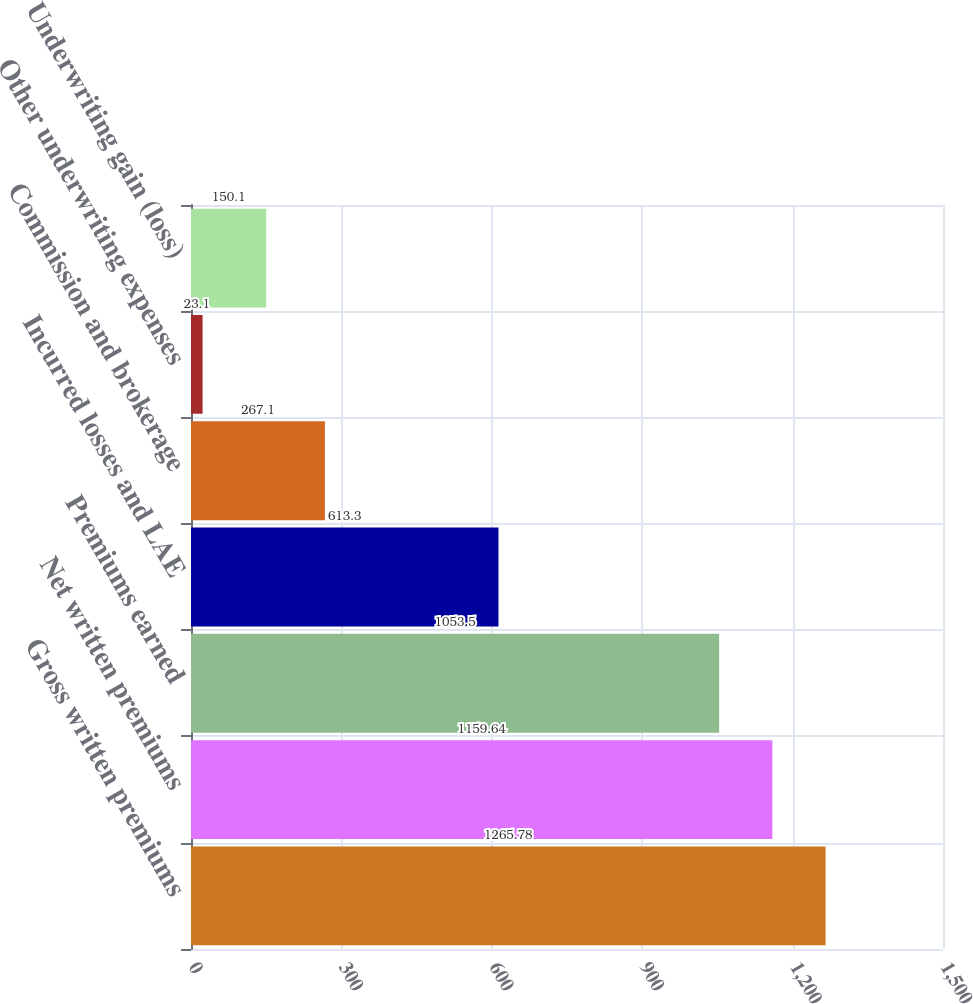Convert chart to OTSL. <chart><loc_0><loc_0><loc_500><loc_500><bar_chart><fcel>Gross written premiums<fcel>Net written premiums<fcel>Premiums earned<fcel>Incurred losses and LAE<fcel>Commission and brokerage<fcel>Other underwriting expenses<fcel>Underwriting gain (loss)<nl><fcel>1265.78<fcel>1159.64<fcel>1053.5<fcel>613.3<fcel>267.1<fcel>23.1<fcel>150.1<nl></chart> 